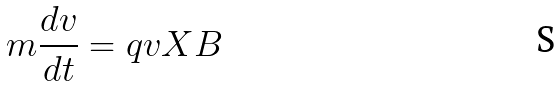Convert formula to latex. <formula><loc_0><loc_0><loc_500><loc_500>m \frac { d v } { d t } = q v X B</formula> 